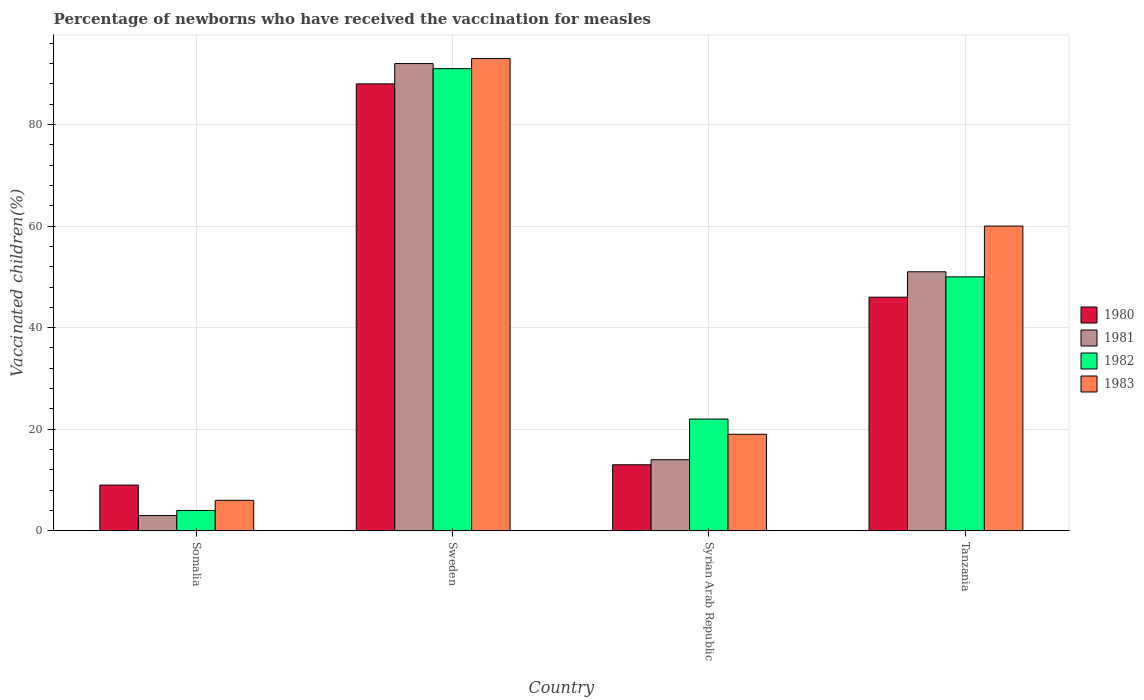How many groups of bars are there?
Provide a succinct answer. 4. Are the number of bars per tick equal to the number of legend labels?
Provide a short and direct response. Yes. Are the number of bars on each tick of the X-axis equal?
Offer a very short reply. Yes. How many bars are there on the 1st tick from the right?
Keep it short and to the point. 4. What is the label of the 4th group of bars from the left?
Offer a very short reply. Tanzania. In how many cases, is the number of bars for a given country not equal to the number of legend labels?
Your answer should be very brief. 0. Across all countries, what is the maximum percentage of vaccinated children in 1983?
Your answer should be very brief. 93. In which country was the percentage of vaccinated children in 1982 maximum?
Make the answer very short. Sweden. In which country was the percentage of vaccinated children in 1981 minimum?
Your answer should be compact. Somalia. What is the total percentage of vaccinated children in 1980 in the graph?
Offer a very short reply. 156. What is the difference between the percentage of vaccinated children in 1980 in Syrian Arab Republic and that in Tanzania?
Make the answer very short. -33. What is the difference between the percentage of vaccinated children in 1982 in Syrian Arab Republic and the percentage of vaccinated children in 1983 in Tanzania?
Your response must be concise. -38. What is the average percentage of vaccinated children in 1980 per country?
Provide a short and direct response. 39. In how many countries, is the percentage of vaccinated children in 1980 greater than 72 %?
Provide a succinct answer. 1. What is the ratio of the percentage of vaccinated children in 1982 in Sweden to that in Tanzania?
Ensure brevity in your answer.  1.82. Is the difference between the percentage of vaccinated children in 1981 in Somalia and Syrian Arab Republic greater than the difference between the percentage of vaccinated children in 1982 in Somalia and Syrian Arab Republic?
Offer a very short reply. Yes. What is the difference between the highest and the second highest percentage of vaccinated children in 1981?
Make the answer very short. -41. What is the difference between the highest and the lowest percentage of vaccinated children in 1982?
Keep it short and to the point. 87. Is it the case that in every country, the sum of the percentage of vaccinated children in 1980 and percentage of vaccinated children in 1982 is greater than the sum of percentage of vaccinated children in 1983 and percentage of vaccinated children in 1981?
Keep it short and to the point. No. What does the 2nd bar from the right in Syrian Arab Republic represents?
Provide a short and direct response. 1982. Are all the bars in the graph horizontal?
Provide a short and direct response. No. How many countries are there in the graph?
Your answer should be very brief. 4. Are the values on the major ticks of Y-axis written in scientific E-notation?
Keep it short and to the point. No. Does the graph contain any zero values?
Offer a very short reply. No. Does the graph contain grids?
Give a very brief answer. Yes. Where does the legend appear in the graph?
Give a very brief answer. Center right. How are the legend labels stacked?
Your answer should be compact. Vertical. What is the title of the graph?
Your answer should be very brief. Percentage of newborns who have received the vaccination for measles. What is the label or title of the X-axis?
Provide a succinct answer. Country. What is the label or title of the Y-axis?
Provide a succinct answer. Vaccinated children(%). What is the Vaccinated children(%) of 1980 in Somalia?
Keep it short and to the point. 9. What is the Vaccinated children(%) in 1982 in Somalia?
Offer a terse response. 4. What is the Vaccinated children(%) in 1980 in Sweden?
Keep it short and to the point. 88. What is the Vaccinated children(%) in 1981 in Sweden?
Your answer should be very brief. 92. What is the Vaccinated children(%) of 1982 in Sweden?
Your answer should be very brief. 91. What is the Vaccinated children(%) of 1983 in Sweden?
Make the answer very short. 93. What is the Vaccinated children(%) of 1983 in Syrian Arab Republic?
Your response must be concise. 19. What is the Vaccinated children(%) of 1980 in Tanzania?
Provide a succinct answer. 46. What is the Vaccinated children(%) of 1981 in Tanzania?
Provide a succinct answer. 51. Across all countries, what is the maximum Vaccinated children(%) in 1980?
Ensure brevity in your answer.  88. Across all countries, what is the maximum Vaccinated children(%) in 1981?
Keep it short and to the point. 92. Across all countries, what is the maximum Vaccinated children(%) of 1982?
Your response must be concise. 91. Across all countries, what is the maximum Vaccinated children(%) of 1983?
Offer a terse response. 93. Across all countries, what is the minimum Vaccinated children(%) of 1982?
Provide a short and direct response. 4. Across all countries, what is the minimum Vaccinated children(%) of 1983?
Offer a very short reply. 6. What is the total Vaccinated children(%) of 1980 in the graph?
Provide a short and direct response. 156. What is the total Vaccinated children(%) in 1981 in the graph?
Offer a terse response. 160. What is the total Vaccinated children(%) in 1982 in the graph?
Make the answer very short. 167. What is the total Vaccinated children(%) in 1983 in the graph?
Provide a succinct answer. 178. What is the difference between the Vaccinated children(%) in 1980 in Somalia and that in Sweden?
Provide a short and direct response. -79. What is the difference between the Vaccinated children(%) of 1981 in Somalia and that in Sweden?
Ensure brevity in your answer.  -89. What is the difference between the Vaccinated children(%) in 1982 in Somalia and that in Sweden?
Offer a terse response. -87. What is the difference between the Vaccinated children(%) in 1983 in Somalia and that in Sweden?
Offer a very short reply. -87. What is the difference between the Vaccinated children(%) in 1982 in Somalia and that in Syrian Arab Republic?
Offer a terse response. -18. What is the difference between the Vaccinated children(%) in 1983 in Somalia and that in Syrian Arab Republic?
Ensure brevity in your answer.  -13. What is the difference between the Vaccinated children(%) in 1980 in Somalia and that in Tanzania?
Give a very brief answer. -37. What is the difference between the Vaccinated children(%) in 1981 in Somalia and that in Tanzania?
Give a very brief answer. -48. What is the difference between the Vaccinated children(%) of 1982 in Somalia and that in Tanzania?
Provide a succinct answer. -46. What is the difference between the Vaccinated children(%) in 1983 in Somalia and that in Tanzania?
Provide a short and direct response. -54. What is the difference between the Vaccinated children(%) of 1980 in Sweden and that in Syrian Arab Republic?
Your answer should be very brief. 75. What is the difference between the Vaccinated children(%) in 1982 in Sweden and that in Syrian Arab Republic?
Give a very brief answer. 69. What is the difference between the Vaccinated children(%) of 1983 in Sweden and that in Syrian Arab Republic?
Your response must be concise. 74. What is the difference between the Vaccinated children(%) of 1980 in Sweden and that in Tanzania?
Offer a terse response. 42. What is the difference between the Vaccinated children(%) of 1981 in Sweden and that in Tanzania?
Your response must be concise. 41. What is the difference between the Vaccinated children(%) of 1983 in Sweden and that in Tanzania?
Provide a short and direct response. 33. What is the difference between the Vaccinated children(%) of 1980 in Syrian Arab Republic and that in Tanzania?
Your answer should be compact. -33. What is the difference between the Vaccinated children(%) of 1981 in Syrian Arab Republic and that in Tanzania?
Make the answer very short. -37. What is the difference between the Vaccinated children(%) in 1983 in Syrian Arab Republic and that in Tanzania?
Your answer should be very brief. -41. What is the difference between the Vaccinated children(%) of 1980 in Somalia and the Vaccinated children(%) of 1981 in Sweden?
Ensure brevity in your answer.  -83. What is the difference between the Vaccinated children(%) of 1980 in Somalia and the Vaccinated children(%) of 1982 in Sweden?
Provide a short and direct response. -82. What is the difference between the Vaccinated children(%) of 1980 in Somalia and the Vaccinated children(%) of 1983 in Sweden?
Ensure brevity in your answer.  -84. What is the difference between the Vaccinated children(%) in 1981 in Somalia and the Vaccinated children(%) in 1982 in Sweden?
Provide a short and direct response. -88. What is the difference between the Vaccinated children(%) of 1981 in Somalia and the Vaccinated children(%) of 1983 in Sweden?
Keep it short and to the point. -90. What is the difference between the Vaccinated children(%) in 1982 in Somalia and the Vaccinated children(%) in 1983 in Sweden?
Offer a very short reply. -89. What is the difference between the Vaccinated children(%) in 1980 in Somalia and the Vaccinated children(%) in 1981 in Syrian Arab Republic?
Offer a terse response. -5. What is the difference between the Vaccinated children(%) of 1980 in Somalia and the Vaccinated children(%) of 1982 in Syrian Arab Republic?
Make the answer very short. -13. What is the difference between the Vaccinated children(%) in 1980 in Somalia and the Vaccinated children(%) in 1983 in Syrian Arab Republic?
Provide a succinct answer. -10. What is the difference between the Vaccinated children(%) in 1982 in Somalia and the Vaccinated children(%) in 1983 in Syrian Arab Republic?
Your response must be concise. -15. What is the difference between the Vaccinated children(%) of 1980 in Somalia and the Vaccinated children(%) of 1981 in Tanzania?
Your response must be concise. -42. What is the difference between the Vaccinated children(%) in 1980 in Somalia and the Vaccinated children(%) in 1982 in Tanzania?
Your response must be concise. -41. What is the difference between the Vaccinated children(%) in 1980 in Somalia and the Vaccinated children(%) in 1983 in Tanzania?
Your answer should be very brief. -51. What is the difference between the Vaccinated children(%) in 1981 in Somalia and the Vaccinated children(%) in 1982 in Tanzania?
Your answer should be compact. -47. What is the difference between the Vaccinated children(%) in 1981 in Somalia and the Vaccinated children(%) in 1983 in Tanzania?
Your answer should be compact. -57. What is the difference between the Vaccinated children(%) in 1982 in Somalia and the Vaccinated children(%) in 1983 in Tanzania?
Provide a short and direct response. -56. What is the difference between the Vaccinated children(%) in 1980 in Sweden and the Vaccinated children(%) in 1981 in Syrian Arab Republic?
Provide a succinct answer. 74. What is the difference between the Vaccinated children(%) in 1982 in Sweden and the Vaccinated children(%) in 1983 in Syrian Arab Republic?
Provide a succinct answer. 72. What is the difference between the Vaccinated children(%) in 1980 in Sweden and the Vaccinated children(%) in 1981 in Tanzania?
Provide a succinct answer. 37. What is the difference between the Vaccinated children(%) of 1982 in Sweden and the Vaccinated children(%) of 1983 in Tanzania?
Keep it short and to the point. 31. What is the difference between the Vaccinated children(%) of 1980 in Syrian Arab Republic and the Vaccinated children(%) of 1981 in Tanzania?
Give a very brief answer. -38. What is the difference between the Vaccinated children(%) of 1980 in Syrian Arab Republic and the Vaccinated children(%) of 1982 in Tanzania?
Your answer should be very brief. -37. What is the difference between the Vaccinated children(%) in 1980 in Syrian Arab Republic and the Vaccinated children(%) in 1983 in Tanzania?
Your response must be concise. -47. What is the difference between the Vaccinated children(%) in 1981 in Syrian Arab Republic and the Vaccinated children(%) in 1982 in Tanzania?
Provide a succinct answer. -36. What is the difference between the Vaccinated children(%) in 1981 in Syrian Arab Republic and the Vaccinated children(%) in 1983 in Tanzania?
Your answer should be very brief. -46. What is the difference between the Vaccinated children(%) in 1982 in Syrian Arab Republic and the Vaccinated children(%) in 1983 in Tanzania?
Keep it short and to the point. -38. What is the average Vaccinated children(%) in 1980 per country?
Offer a very short reply. 39. What is the average Vaccinated children(%) in 1982 per country?
Keep it short and to the point. 41.75. What is the average Vaccinated children(%) of 1983 per country?
Your response must be concise. 44.5. What is the difference between the Vaccinated children(%) of 1980 and Vaccinated children(%) of 1982 in Somalia?
Make the answer very short. 5. What is the difference between the Vaccinated children(%) in 1981 and Vaccinated children(%) in 1982 in Somalia?
Offer a very short reply. -1. What is the difference between the Vaccinated children(%) of 1980 and Vaccinated children(%) of 1981 in Sweden?
Ensure brevity in your answer.  -4. What is the difference between the Vaccinated children(%) of 1980 and Vaccinated children(%) of 1982 in Sweden?
Provide a short and direct response. -3. What is the difference between the Vaccinated children(%) in 1980 and Vaccinated children(%) in 1983 in Sweden?
Offer a very short reply. -5. What is the difference between the Vaccinated children(%) of 1982 and Vaccinated children(%) of 1983 in Sweden?
Keep it short and to the point. -2. What is the difference between the Vaccinated children(%) in 1980 and Vaccinated children(%) in 1982 in Syrian Arab Republic?
Keep it short and to the point. -9. What is the difference between the Vaccinated children(%) of 1981 and Vaccinated children(%) of 1982 in Syrian Arab Republic?
Your response must be concise. -8. What is the difference between the Vaccinated children(%) in 1981 and Vaccinated children(%) in 1983 in Syrian Arab Republic?
Provide a succinct answer. -5. What is the difference between the Vaccinated children(%) of 1980 and Vaccinated children(%) of 1982 in Tanzania?
Keep it short and to the point. -4. What is the difference between the Vaccinated children(%) in 1980 and Vaccinated children(%) in 1983 in Tanzania?
Your answer should be compact. -14. What is the difference between the Vaccinated children(%) of 1981 and Vaccinated children(%) of 1982 in Tanzania?
Offer a terse response. 1. What is the difference between the Vaccinated children(%) in 1981 and Vaccinated children(%) in 1983 in Tanzania?
Give a very brief answer. -9. What is the difference between the Vaccinated children(%) of 1982 and Vaccinated children(%) of 1983 in Tanzania?
Your answer should be compact. -10. What is the ratio of the Vaccinated children(%) in 1980 in Somalia to that in Sweden?
Ensure brevity in your answer.  0.1. What is the ratio of the Vaccinated children(%) in 1981 in Somalia to that in Sweden?
Keep it short and to the point. 0.03. What is the ratio of the Vaccinated children(%) in 1982 in Somalia to that in Sweden?
Provide a succinct answer. 0.04. What is the ratio of the Vaccinated children(%) in 1983 in Somalia to that in Sweden?
Provide a short and direct response. 0.06. What is the ratio of the Vaccinated children(%) of 1980 in Somalia to that in Syrian Arab Republic?
Make the answer very short. 0.69. What is the ratio of the Vaccinated children(%) of 1981 in Somalia to that in Syrian Arab Republic?
Make the answer very short. 0.21. What is the ratio of the Vaccinated children(%) of 1982 in Somalia to that in Syrian Arab Republic?
Provide a short and direct response. 0.18. What is the ratio of the Vaccinated children(%) of 1983 in Somalia to that in Syrian Arab Republic?
Give a very brief answer. 0.32. What is the ratio of the Vaccinated children(%) in 1980 in Somalia to that in Tanzania?
Your answer should be compact. 0.2. What is the ratio of the Vaccinated children(%) of 1981 in Somalia to that in Tanzania?
Give a very brief answer. 0.06. What is the ratio of the Vaccinated children(%) of 1982 in Somalia to that in Tanzania?
Ensure brevity in your answer.  0.08. What is the ratio of the Vaccinated children(%) of 1980 in Sweden to that in Syrian Arab Republic?
Provide a succinct answer. 6.77. What is the ratio of the Vaccinated children(%) in 1981 in Sweden to that in Syrian Arab Republic?
Offer a terse response. 6.57. What is the ratio of the Vaccinated children(%) in 1982 in Sweden to that in Syrian Arab Republic?
Your answer should be very brief. 4.14. What is the ratio of the Vaccinated children(%) of 1983 in Sweden to that in Syrian Arab Republic?
Provide a short and direct response. 4.89. What is the ratio of the Vaccinated children(%) of 1980 in Sweden to that in Tanzania?
Provide a succinct answer. 1.91. What is the ratio of the Vaccinated children(%) of 1981 in Sweden to that in Tanzania?
Make the answer very short. 1.8. What is the ratio of the Vaccinated children(%) of 1982 in Sweden to that in Tanzania?
Your response must be concise. 1.82. What is the ratio of the Vaccinated children(%) in 1983 in Sweden to that in Tanzania?
Make the answer very short. 1.55. What is the ratio of the Vaccinated children(%) of 1980 in Syrian Arab Republic to that in Tanzania?
Keep it short and to the point. 0.28. What is the ratio of the Vaccinated children(%) of 1981 in Syrian Arab Republic to that in Tanzania?
Ensure brevity in your answer.  0.27. What is the ratio of the Vaccinated children(%) of 1982 in Syrian Arab Republic to that in Tanzania?
Offer a terse response. 0.44. What is the ratio of the Vaccinated children(%) in 1983 in Syrian Arab Republic to that in Tanzania?
Make the answer very short. 0.32. What is the difference between the highest and the second highest Vaccinated children(%) of 1980?
Keep it short and to the point. 42. What is the difference between the highest and the second highest Vaccinated children(%) of 1981?
Make the answer very short. 41. What is the difference between the highest and the second highest Vaccinated children(%) in 1983?
Ensure brevity in your answer.  33. What is the difference between the highest and the lowest Vaccinated children(%) in 1980?
Ensure brevity in your answer.  79. What is the difference between the highest and the lowest Vaccinated children(%) of 1981?
Keep it short and to the point. 89. What is the difference between the highest and the lowest Vaccinated children(%) in 1982?
Your answer should be very brief. 87. What is the difference between the highest and the lowest Vaccinated children(%) in 1983?
Keep it short and to the point. 87. 